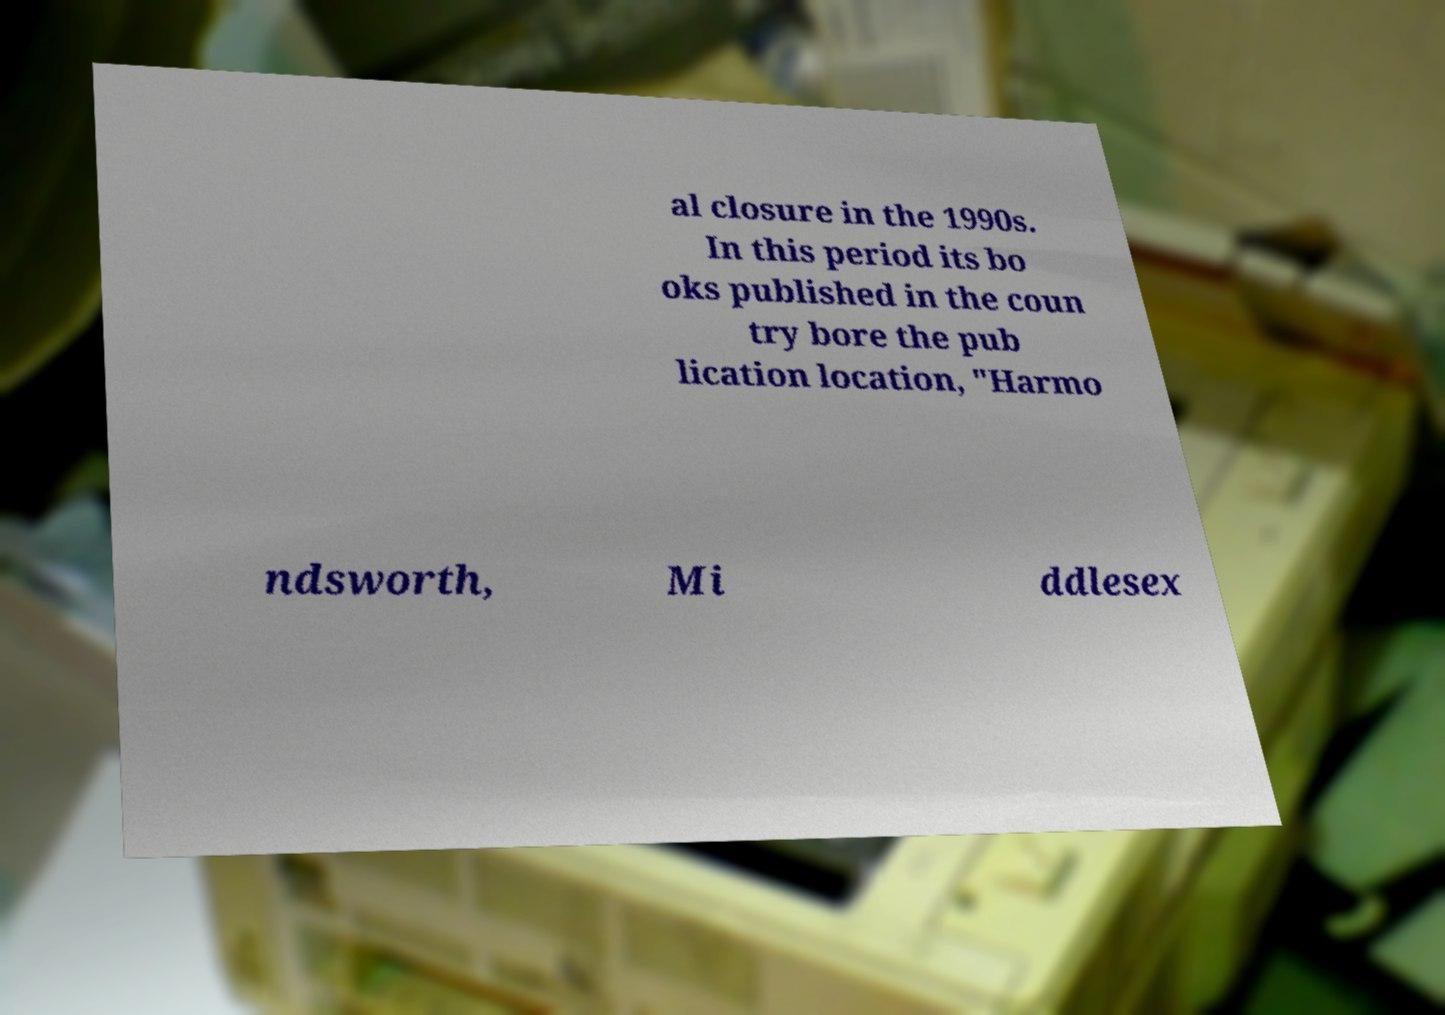Please identify and transcribe the text found in this image. al closure in the 1990s. In this period its bo oks published in the coun try bore the pub lication location, "Harmo ndsworth, Mi ddlesex 